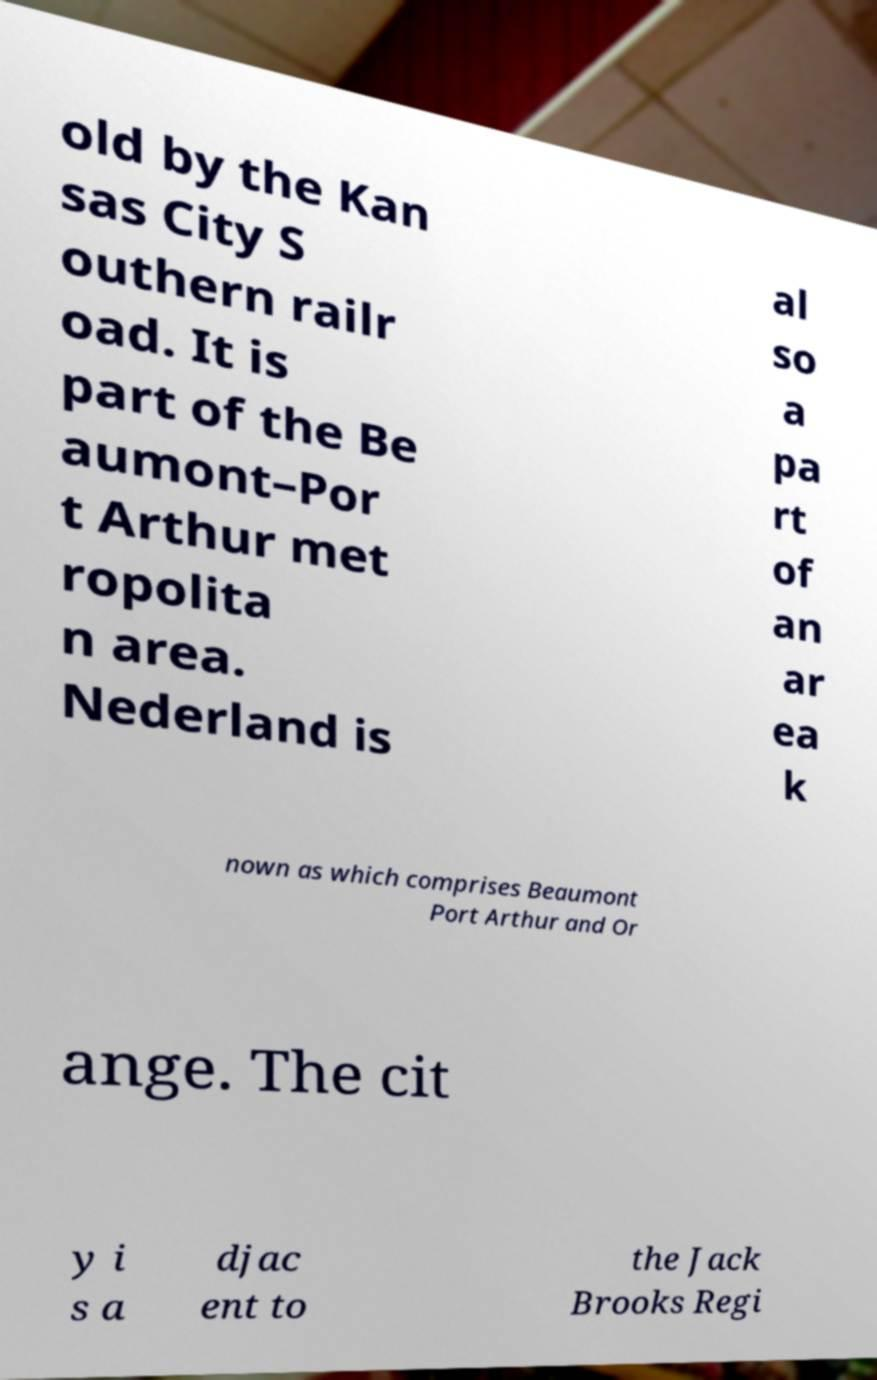For documentation purposes, I need the text within this image transcribed. Could you provide that? old by the Kan sas City S outhern railr oad. It is part of the Be aumont–Por t Arthur met ropolita n area. Nederland is al so a pa rt of an ar ea k nown as which comprises Beaumont Port Arthur and Or ange. The cit y i s a djac ent to the Jack Brooks Regi 